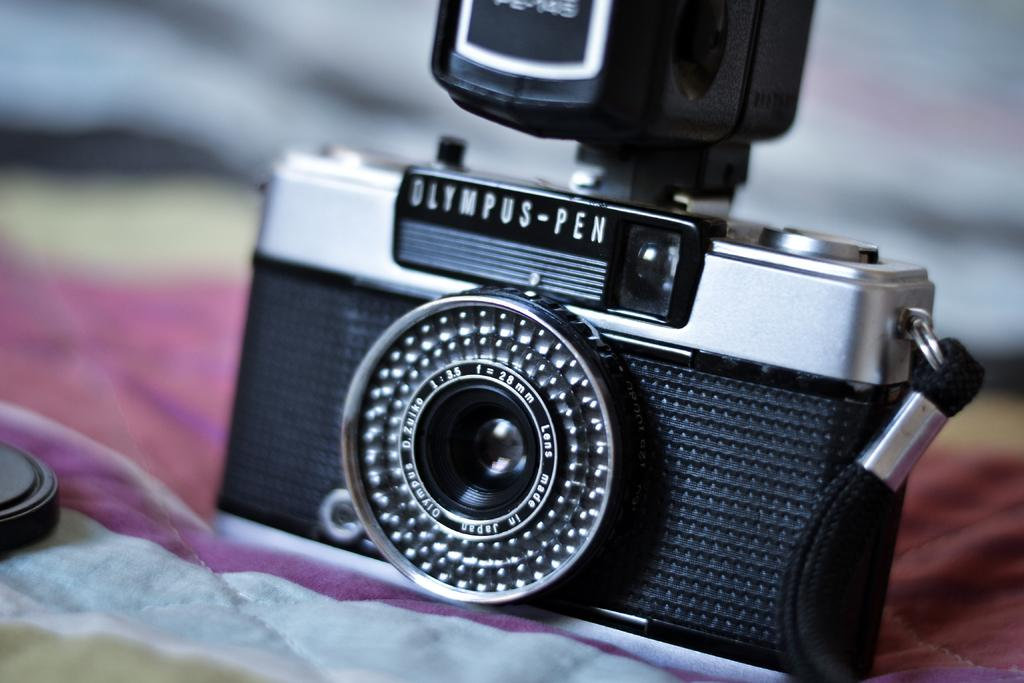What is the main subject of the image? The main subject of the image is a camera. Where is the camera placed in the image? The camera is on a cloth in the image. How would you describe the background of the image? The background of the image is blurry. What can be seen on the left side of the image? There is an object on the left side of the image. What type of can is visible on the right side of the image? There is no can present in the image; it only features a camera, a cloth, a blurry background, and an object on the left side. 